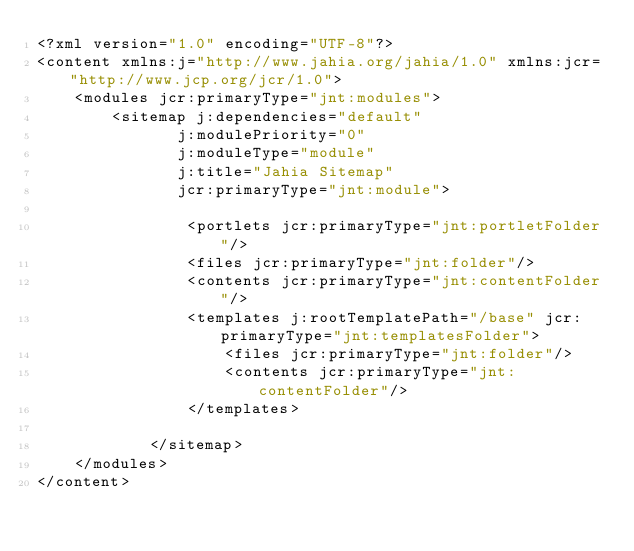Convert code to text. <code><loc_0><loc_0><loc_500><loc_500><_XML_><?xml version="1.0" encoding="UTF-8"?>
<content xmlns:j="http://www.jahia.org/jahia/1.0" xmlns:jcr="http://www.jcp.org/jcr/1.0">
    <modules jcr:primaryType="jnt:modules">
        <sitemap j:dependencies="default"
               j:modulePriority="0"
               j:moduleType="module"
               j:title="Jahia Sitemap"
               jcr:primaryType="jnt:module">
                
                <portlets jcr:primaryType="jnt:portletFolder"/>
                <files jcr:primaryType="jnt:folder"/>
                <contents jcr:primaryType="jnt:contentFolder"/>
                <templates j:rootTemplatePath="/base" jcr:primaryType="jnt:templatesFolder">
                    <files jcr:primaryType="jnt:folder"/>
                    <contents jcr:primaryType="jnt:contentFolder"/>
                </templates>
                
            </sitemap>
    </modules>
</content>
</code> 